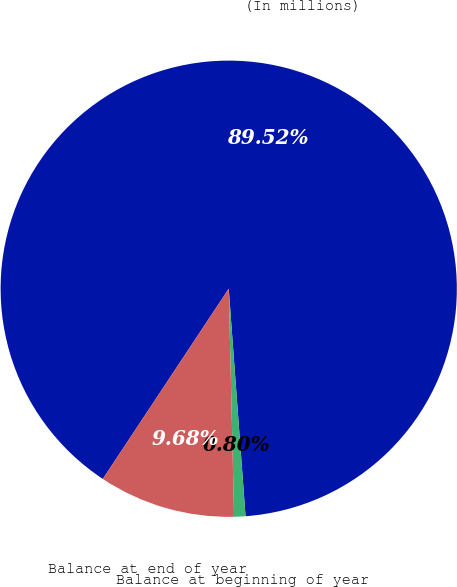Convert chart. <chart><loc_0><loc_0><loc_500><loc_500><pie_chart><fcel>(In millions)<fcel>Balance at beginning of year<fcel>Balance at end of year<nl><fcel>89.52%<fcel>0.8%<fcel>9.68%<nl></chart> 